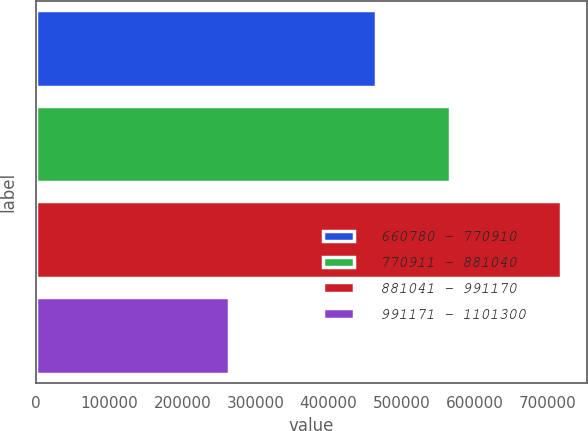Convert chart to OTSL. <chart><loc_0><loc_0><loc_500><loc_500><bar_chart><fcel>660780 - 770910<fcel>770911 - 881040<fcel>881041 - 991170<fcel>991171 - 1101300<nl><fcel>464810<fcel>566050<fcel>717550<fcel>263754<nl></chart> 